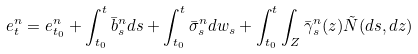Convert formula to latex. <formula><loc_0><loc_0><loc_500><loc_500>e ^ { n } _ { t } = e ^ { n } _ { t _ { 0 } } + \int _ { t _ { 0 } } ^ { t } \bar { b } _ { s } ^ { n } d s + \int _ { t _ { 0 } } ^ { t } \bar { \sigma } _ { s } ^ { n } d w _ { s } + \int _ { t _ { 0 } } ^ { t } \int _ { Z } \bar { \gamma } _ { s } ^ { n } ( z ) \tilde { N } ( d s , d z )</formula> 